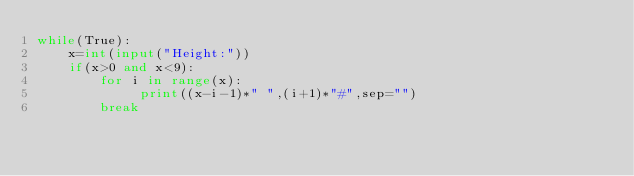Convert code to text. <code><loc_0><loc_0><loc_500><loc_500><_Python_>while(True):
    x=int(input("Height:"))
    if(x>0 and x<9):
        for i in range(x):
             print((x-i-1)*" ",(i+1)*"#",sep="")
        break
</code> 